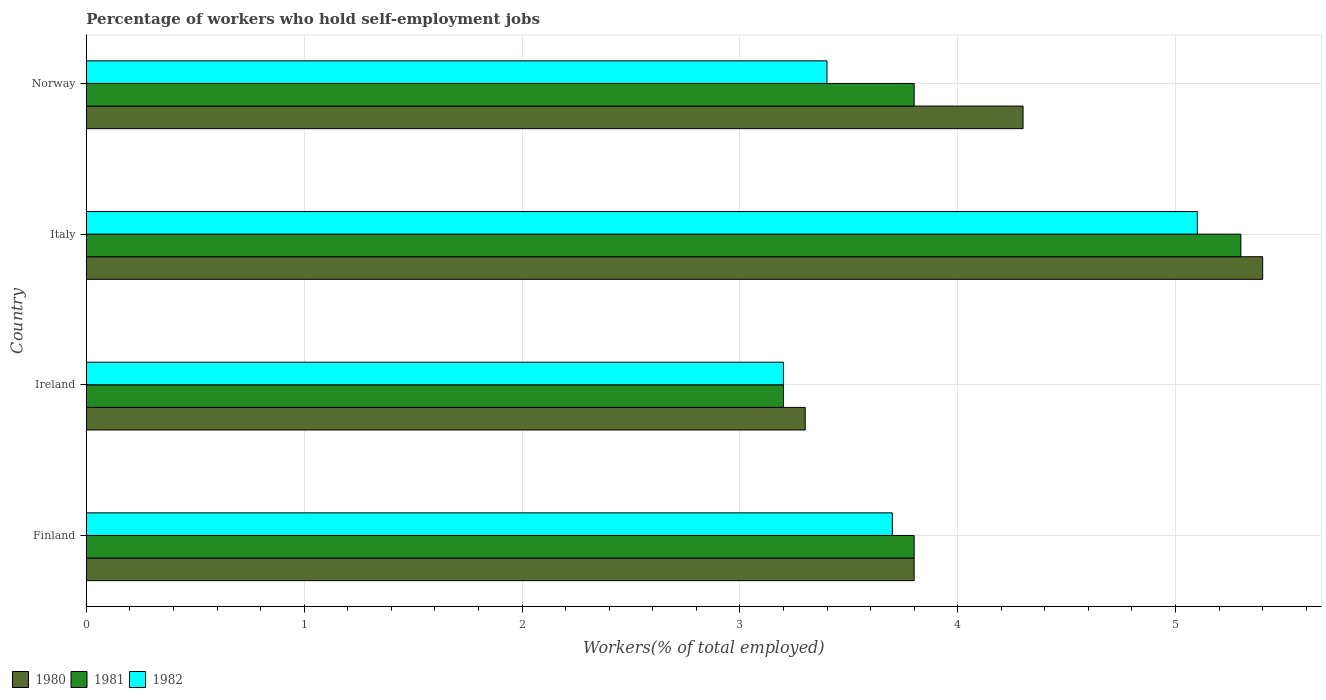How many groups of bars are there?
Give a very brief answer. 4. Are the number of bars per tick equal to the number of legend labels?
Make the answer very short. Yes. Are the number of bars on each tick of the Y-axis equal?
Make the answer very short. Yes. In how many cases, is the number of bars for a given country not equal to the number of legend labels?
Ensure brevity in your answer.  0. What is the percentage of self-employed workers in 1980 in Ireland?
Provide a short and direct response. 3.3. Across all countries, what is the maximum percentage of self-employed workers in 1982?
Provide a short and direct response. 5.1. Across all countries, what is the minimum percentage of self-employed workers in 1980?
Your answer should be compact. 3.3. In which country was the percentage of self-employed workers in 1982 minimum?
Your answer should be compact. Ireland. What is the total percentage of self-employed workers in 1982 in the graph?
Ensure brevity in your answer.  15.4. What is the difference between the percentage of self-employed workers in 1980 in Italy and that in Norway?
Your answer should be compact. 1.1. What is the difference between the percentage of self-employed workers in 1980 in Italy and the percentage of self-employed workers in 1982 in Norway?
Keep it short and to the point. 2. What is the average percentage of self-employed workers in 1982 per country?
Give a very brief answer. 3.85. What is the difference between the percentage of self-employed workers in 1980 and percentage of self-employed workers in 1982 in Italy?
Provide a succinct answer. 0.3. What is the ratio of the percentage of self-employed workers in 1980 in Ireland to that in Norway?
Offer a very short reply. 0.77. What is the difference between the highest and the second highest percentage of self-employed workers in 1982?
Give a very brief answer. 1.4. What is the difference between the highest and the lowest percentage of self-employed workers in 1980?
Your answer should be compact. 2.1. In how many countries, is the percentage of self-employed workers in 1981 greater than the average percentage of self-employed workers in 1981 taken over all countries?
Provide a succinct answer. 1. What does the 1st bar from the top in Ireland represents?
Provide a short and direct response. 1982. What does the 2nd bar from the bottom in Ireland represents?
Provide a short and direct response. 1981. Is it the case that in every country, the sum of the percentage of self-employed workers in 1982 and percentage of self-employed workers in 1980 is greater than the percentage of self-employed workers in 1981?
Your response must be concise. Yes. How many bars are there?
Make the answer very short. 12. Are all the bars in the graph horizontal?
Offer a very short reply. Yes. How many countries are there in the graph?
Provide a short and direct response. 4. Are the values on the major ticks of X-axis written in scientific E-notation?
Your response must be concise. No. Does the graph contain grids?
Ensure brevity in your answer.  Yes. Where does the legend appear in the graph?
Make the answer very short. Bottom left. How many legend labels are there?
Give a very brief answer. 3. How are the legend labels stacked?
Make the answer very short. Horizontal. What is the title of the graph?
Offer a very short reply. Percentage of workers who hold self-employment jobs. Does "2004" appear as one of the legend labels in the graph?
Your response must be concise. No. What is the label or title of the X-axis?
Offer a terse response. Workers(% of total employed). What is the label or title of the Y-axis?
Provide a short and direct response. Country. What is the Workers(% of total employed) in 1980 in Finland?
Ensure brevity in your answer.  3.8. What is the Workers(% of total employed) in 1981 in Finland?
Your response must be concise. 3.8. What is the Workers(% of total employed) in 1982 in Finland?
Give a very brief answer. 3.7. What is the Workers(% of total employed) of 1980 in Ireland?
Your response must be concise. 3.3. What is the Workers(% of total employed) in 1981 in Ireland?
Your response must be concise. 3.2. What is the Workers(% of total employed) of 1982 in Ireland?
Offer a terse response. 3.2. What is the Workers(% of total employed) of 1980 in Italy?
Give a very brief answer. 5.4. What is the Workers(% of total employed) of 1981 in Italy?
Ensure brevity in your answer.  5.3. What is the Workers(% of total employed) of 1982 in Italy?
Make the answer very short. 5.1. What is the Workers(% of total employed) in 1980 in Norway?
Offer a very short reply. 4.3. What is the Workers(% of total employed) of 1981 in Norway?
Provide a succinct answer. 3.8. What is the Workers(% of total employed) in 1982 in Norway?
Your answer should be compact. 3.4. Across all countries, what is the maximum Workers(% of total employed) of 1980?
Provide a succinct answer. 5.4. Across all countries, what is the maximum Workers(% of total employed) of 1981?
Offer a very short reply. 5.3. Across all countries, what is the maximum Workers(% of total employed) of 1982?
Offer a very short reply. 5.1. Across all countries, what is the minimum Workers(% of total employed) in 1980?
Your response must be concise. 3.3. Across all countries, what is the minimum Workers(% of total employed) in 1981?
Offer a terse response. 3.2. Across all countries, what is the minimum Workers(% of total employed) in 1982?
Provide a short and direct response. 3.2. What is the difference between the Workers(% of total employed) of 1982 in Finland and that in Ireland?
Your answer should be compact. 0.5. What is the difference between the Workers(% of total employed) in 1981 in Finland and that in Italy?
Make the answer very short. -1.5. What is the difference between the Workers(% of total employed) of 1982 in Finland and that in Italy?
Offer a very short reply. -1.4. What is the difference between the Workers(% of total employed) in 1980 in Finland and that in Norway?
Provide a succinct answer. -0.5. What is the difference between the Workers(% of total employed) of 1981 in Finland and that in Norway?
Provide a short and direct response. 0. What is the difference between the Workers(% of total employed) of 1982 in Finland and that in Norway?
Offer a terse response. 0.3. What is the difference between the Workers(% of total employed) in 1981 in Ireland and that in Italy?
Give a very brief answer. -2.1. What is the difference between the Workers(% of total employed) in 1982 in Ireland and that in Italy?
Provide a succinct answer. -1.9. What is the difference between the Workers(% of total employed) of 1981 in Ireland and that in Norway?
Keep it short and to the point. -0.6. What is the difference between the Workers(% of total employed) in 1980 in Italy and that in Norway?
Provide a short and direct response. 1.1. What is the difference between the Workers(% of total employed) in 1981 in Italy and that in Norway?
Give a very brief answer. 1.5. What is the difference between the Workers(% of total employed) of 1980 in Finland and the Workers(% of total employed) of 1981 in Ireland?
Ensure brevity in your answer.  0.6. What is the difference between the Workers(% of total employed) in 1980 in Finland and the Workers(% of total employed) in 1981 in Italy?
Ensure brevity in your answer.  -1.5. What is the difference between the Workers(% of total employed) in 1980 in Finland and the Workers(% of total employed) in 1982 in Italy?
Offer a terse response. -1.3. What is the difference between the Workers(% of total employed) in 1980 in Finland and the Workers(% of total employed) in 1981 in Norway?
Your response must be concise. 0. What is the difference between the Workers(% of total employed) in 1980 in Ireland and the Workers(% of total employed) in 1981 in Italy?
Ensure brevity in your answer.  -2. What is the difference between the Workers(% of total employed) in 1980 in Ireland and the Workers(% of total employed) in 1982 in Italy?
Keep it short and to the point. -1.8. What is the difference between the Workers(% of total employed) in 1981 in Ireland and the Workers(% of total employed) in 1982 in Italy?
Offer a terse response. -1.9. What is the difference between the Workers(% of total employed) of 1980 in Ireland and the Workers(% of total employed) of 1981 in Norway?
Ensure brevity in your answer.  -0.5. What is the difference between the Workers(% of total employed) of 1980 in Italy and the Workers(% of total employed) of 1981 in Norway?
Offer a terse response. 1.6. What is the difference between the Workers(% of total employed) of 1981 in Italy and the Workers(% of total employed) of 1982 in Norway?
Offer a very short reply. 1.9. What is the average Workers(% of total employed) of 1980 per country?
Offer a terse response. 4.2. What is the average Workers(% of total employed) in 1981 per country?
Your answer should be very brief. 4.03. What is the average Workers(% of total employed) of 1982 per country?
Ensure brevity in your answer.  3.85. What is the difference between the Workers(% of total employed) of 1980 and Workers(% of total employed) of 1981 in Finland?
Provide a short and direct response. 0. What is the difference between the Workers(% of total employed) in 1980 and Workers(% of total employed) in 1982 in Finland?
Make the answer very short. 0.1. What is the difference between the Workers(% of total employed) of 1981 and Workers(% of total employed) of 1982 in Finland?
Make the answer very short. 0.1. What is the difference between the Workers(% of total employed) in 1980 and Workers(% of total employed) in 1982 in Ireland?
Your answer should be very brief. 0.1. What is the difference between the Workers(% of total employed) in 1980 and Workers(% of total employed) in 1981 in Norway?
Provide a short and direct response. 0.5. What is the difference between the Workers(% of total employed) of 1980 and Workers(% of total employed) of 1982 in Norway?
Offer a terse response. 0.9. What is the ratio of the Workers(% of total employed) in 1980 in Finland to that in Ireland?
Give a very brief answer. 1.15. What is the ratio of the Workers(% of total employed) in 1981 in Finland to that in Ireland?
Ensure brevity in your answer.  1.19. What is the ratio of the Workers(% of total employed) in 1982 in Finland to that in Ireland?
Offer a very short reply. 1.16. What is the ratio of the Workers(% of total employed) of 1980 in Finland to that in Italy?
Your answer should be compact. 0.7. What is the ratio of the Workers(% of total employed) of 1981 in Finland to that in Italy?
Give a very brief answer. 0.72. What is the ratio of the Workers(% of total employed) of 1982 in Finland to that in Italy?
Your response must be concise. 0.73. What is the ratio of the Workers(% of total employed) of 1980 in Finland to that in Norway?
Provide a short and direct response. 0.88. What is the ratio of the Workers(% of total employed) of 1982 in Finland to that in Norway?
Keep it short and to the point. 1.09. What is the ratio of the Workers(% of total employed) in 1980 in Ireland to that in Italy?
Your response must be concise. 0.61. What is the ratio of the Workers(% of total employed) in 1981 in Ireland to that in Italy?
Keep it short and to the point. 0.6. What is the ratio of the Workers(% of total employed) in 1982 in Ireland to that in Italy?
Make the answer very short. 0.63. What is the ratio of the Workers(% of total employed) in 1980 in Ireland to that in Norway?
Provide a short and direct response. 0.77. What is the ratio of the Workers(% of total employed) of 1981 in Ireland to that in Norway?
Give a very brief answer. 0.84. What is the ratio of the Workers(% of total employed) of 1982 in Ireland to that in Norway?
Offer a terse response. 0.94. What is the ratio of the Workers(% of total employed) in 1980 in Italy to that in Norway?
Your answer should be compact. 1.26. What is the ratio of the Workers(% of total employed) in 1981 in Italy to that in Norway?
Offer a very short reply. 1.39. What is the ratio of the Workers(% of total employed) in 1982 in Italy to that in Norway?
Your answer should be compact. 1.5. What is the difference between the highest and the lowest Workers(% of total employed) in 1982?
Provide a succinct answer. 1.9. 